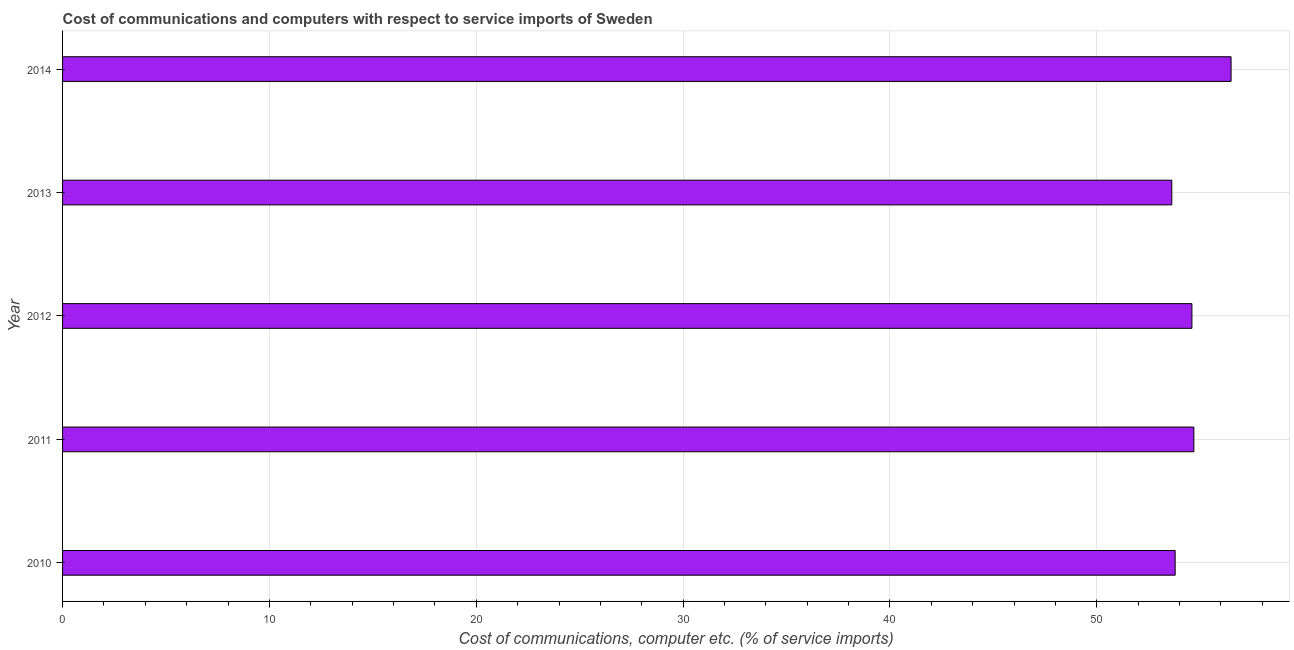What is the title of the graph?
Your answer should be very brief. Cost of communications and computers with respect to service imports of Sweden. What is the label or title of the X-axis?
Your response must be concise. Cost of communications, computer etc. (% of service imports). What is the label or title of the Y-axis?
Offer a very short reply. Year. What is the cost of communications and computer in 2013?
Give a very brief answer. 53.62. Across all years, what is the maximum cost of communications and computer?
Offer a very short reply. 56.49. Across all years, what is the minimum cost of communications and computer?
Offer a very short reply. 53.62. In which year was the cost of communications and computer maximum?
Keep it short and to the point. 2014. In which year was the cost of communications and computer minimum?
Offer a terse response. 2013. What is the sum of the cost of communications and computer?
Your answer should be very brief. 273.19. What is the difference between the cost of communications and computer in 2011 and 2013?
Offer a very short reply. 1.07. What is the average cost of communications and computer per year?
Provide a succinct answer. 54.64. What is the median cost of communications and computer?
Provide a succinct answer. 54.6. Is the difference between the cost of communications and computer in 2011 and 2013 greater than the difference between any two years?
Ensure brevity in your answer.  No. What is the difference between the highest and the second highest cost of communications and computer?
Ensure brevity in your answer.  1.8. What is the difference between the highest and the lowest cost of communications and computer?
Give a very brief answer. 2.87. In how many years, is the cost of communications and computer greater than the average cost of communications and computer taken over all years?
Provide a succinct answer. 2. Are all the bars in the graph horizontal?
Your response must be concise. Yes. How many years are there in the graph?
Make the answer very short. 5. Are the values on the major ticks of X-axis written in scientific E-notation?
Give a very brief answer. No. What is the Cost of communications, computer etc. (% of service imports) in 2010?
Your response must be concise. 53.79. What is the Cost of communications, computer etc. (% of service imports) of 2011?
Provide a short and direct response. 54.69. What is the Cost of communications, computer etc. (% of service imports) of 2012?
Keep it short and to the point. 54.6. What is the Cost of communications, computer etc. (% of service imports) in 2013?
Provide a short and direct response. 53.62. What is the Cost of communications, computer etc. (% of service imports) of 2014?
Give a very brief answer. 56.49. What is the difference between the Cost of communications, computer etc. (% of service imports) in 2010 and 2011?
Ensure brevity in your answer.  -0.9. What is the difference between the Cost of communications, computer etc. (% of service imports) in 2010 and 2012?
Your answer should be very brief. -0.81. What is the difference between the Cost of communications, computer etc. (% of service imports) in 2010 and 2013?
Offer a terse response. 0.16. What is the difference between the Cost of communications, computer etc. (% of service imports) in 2010 and 2014?
Give a very brief answer. -2.7. What is the difference between the Cost of communications, computer etc. (% of service imports) in 2011 and 2012?
Offer a terse response. 0.09. What is the difference between the Cost of communications, computer etc. (% of service imports) in 2011 and 2013?
Provide a succinct answer. 1.07. What is the difference between the Cost of communications, computer etc. (% of service imports) in 2011 and 2014?
Make the answer very short. -1.8. What is the difference between the Cost of communications, computer etc. (% of service imports) in 2012 and 2013?
Give a very brief answer. 0.97. What is the difference between the Cost of communications, computer etc. (% of service imports) in 2012 and 2014?
Ensure brevity in your answer.  -1.89. What is the difference between the Cost of communications, computer etc. (% of service imports) in 2013 and 2014?
Make the answer very short. -2.87. What is the ratio of the Cost of communications, computer etc. (% of service imports) in 2010 to that in 2012?
Offer a very short reply. 0.98. What is the ratio of the Cost of communications, computer etc. (% of service imports) in 2010 to that in 2014?
Ensure brevity in your answer.  0.95. What is the ratio of the Cost of communications, computer etc. (% of service imports) in 2011 to that in 2012?
Keep it short and to the point. 1. What is the ratio of the Cost of communications, computer etc. (% of service imports) in 2012 to that in 2013?
Offer a terse response. 1.02. What is the ratio of the Cost of communications, computer etc. (% of service imports) in 2012 to that in 2014?
Offer a terse response. 0.97. What is the ratio of the Cost of communications, computer etc. (% of service imports) in 2013 to that in 2014?
Your answer should be compact. 0.95. 